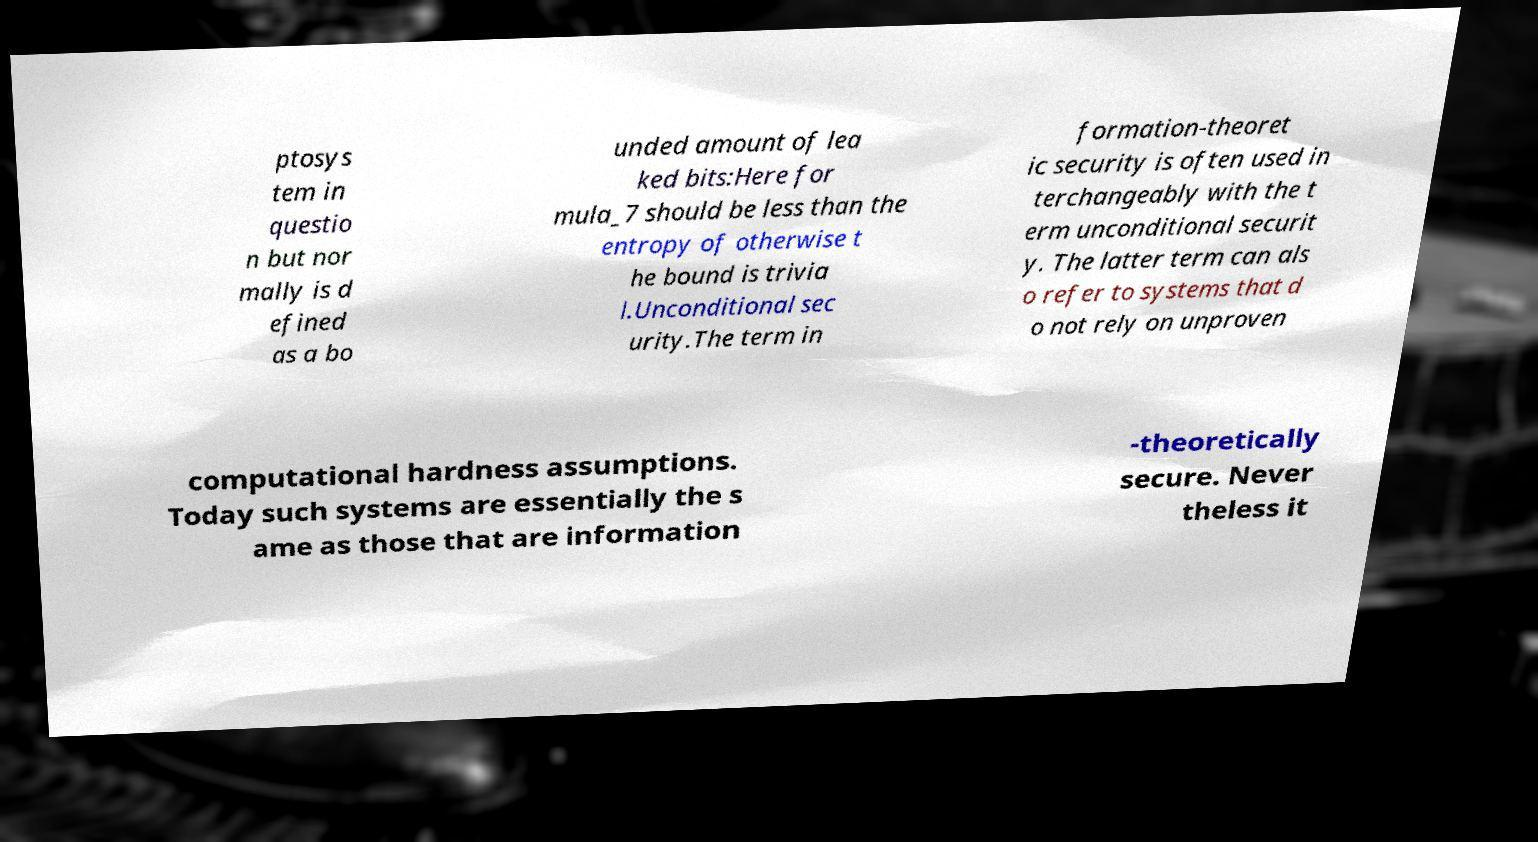Could you assist in decoding the text presented in this image and type it out clearly? ptosys tem in questio n but nor mally is d efined as a bo unded amount of lea ked bits:Here for mula_7 should be less than the entropy of otherwise t he bound is trivia l.Unconditional sec urity.The term in formation-theoret ic security is often used in terchangeably with the t erm unconditional securit y. The latter term can als o refer to systems that d o not rely on unproven computational hardness assumptions. Today such systems are essentially the s ame as those that are information -theoretically secure. Never theless it 